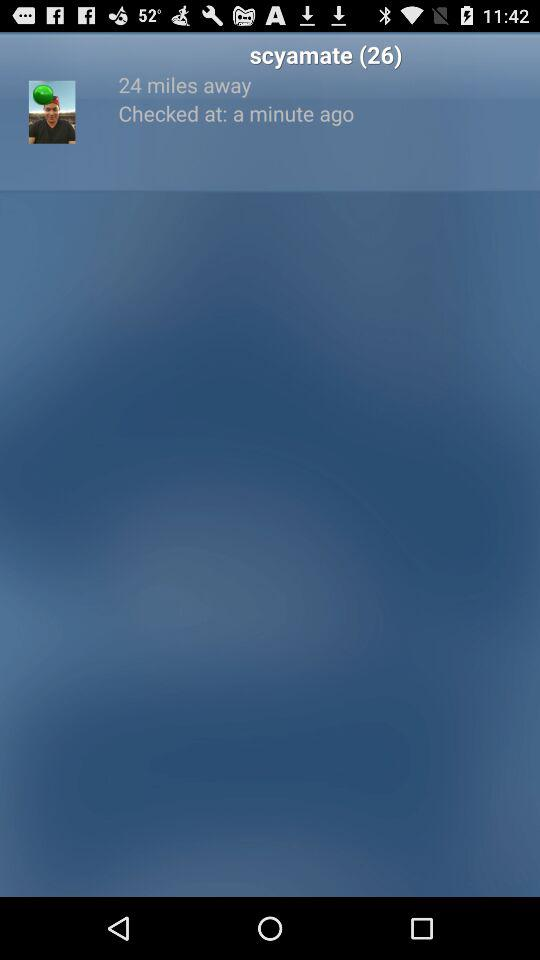What is the user name? The user name is Scyamate. 